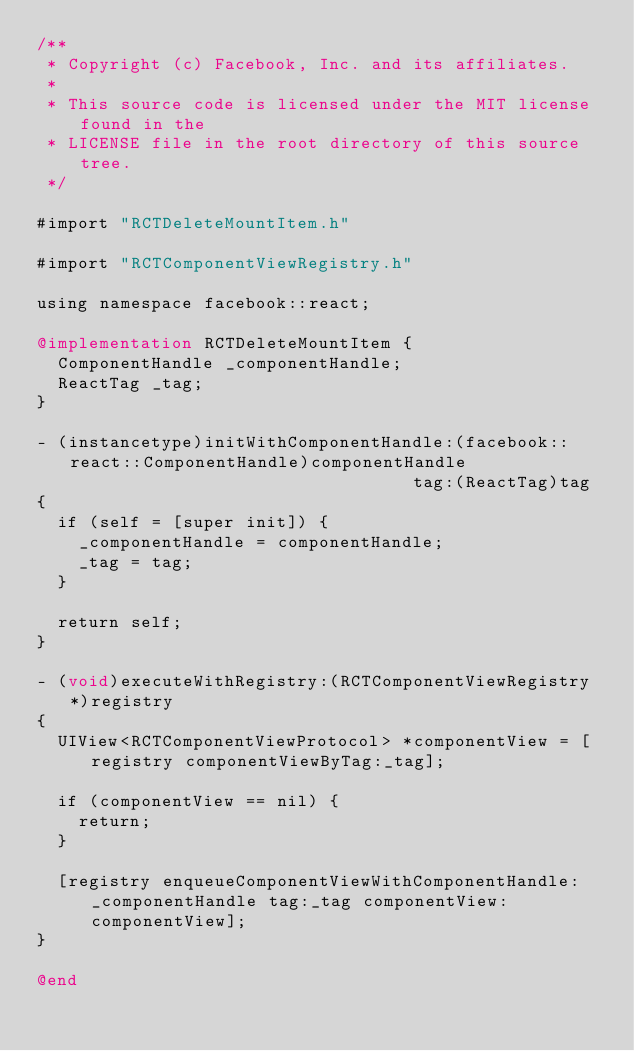<code> <loc_0><loc_0><loc_500><loc_500><_ObjectiveC_>/**
 * Copyright (c) Facebook, Inc. and its affiliates.
 *
 * This source code is licensed under the MIT license found in the
 * LICENSE file in the root directory of this source tree.
 */

#import "RCTDeleteMountItem.h"

#import "RCTComponentViewRegistry.h"

using namespace facebook::react;

@implementation RCTDeleteMountItem {
  ComponentHandle _componentHandle;
  ReactTag _tag;
}

- (instancetype)initWithComponentHandle:(facebook::react::ComponentHandle)componentHandle
                                    tag:(ReactTag)tag
{
  if (self = [super init]) {
    _componentHandle = componentHandle;
    _tag = tag;
  }

  return self;
}

- (void)executeWithRegistry:(RCTComponentViewRegistry *)registry
{
  UIView<RCTComponentViewProtocol> *componentView = [registry componentViewByTag:_tag];

  if (componentView == nil) {
    return;
  }

  [registry enqueueComponentViewWithComponentHandle:_componentHandle tag:_tag componentView:componentView];
}

@end
</code> 